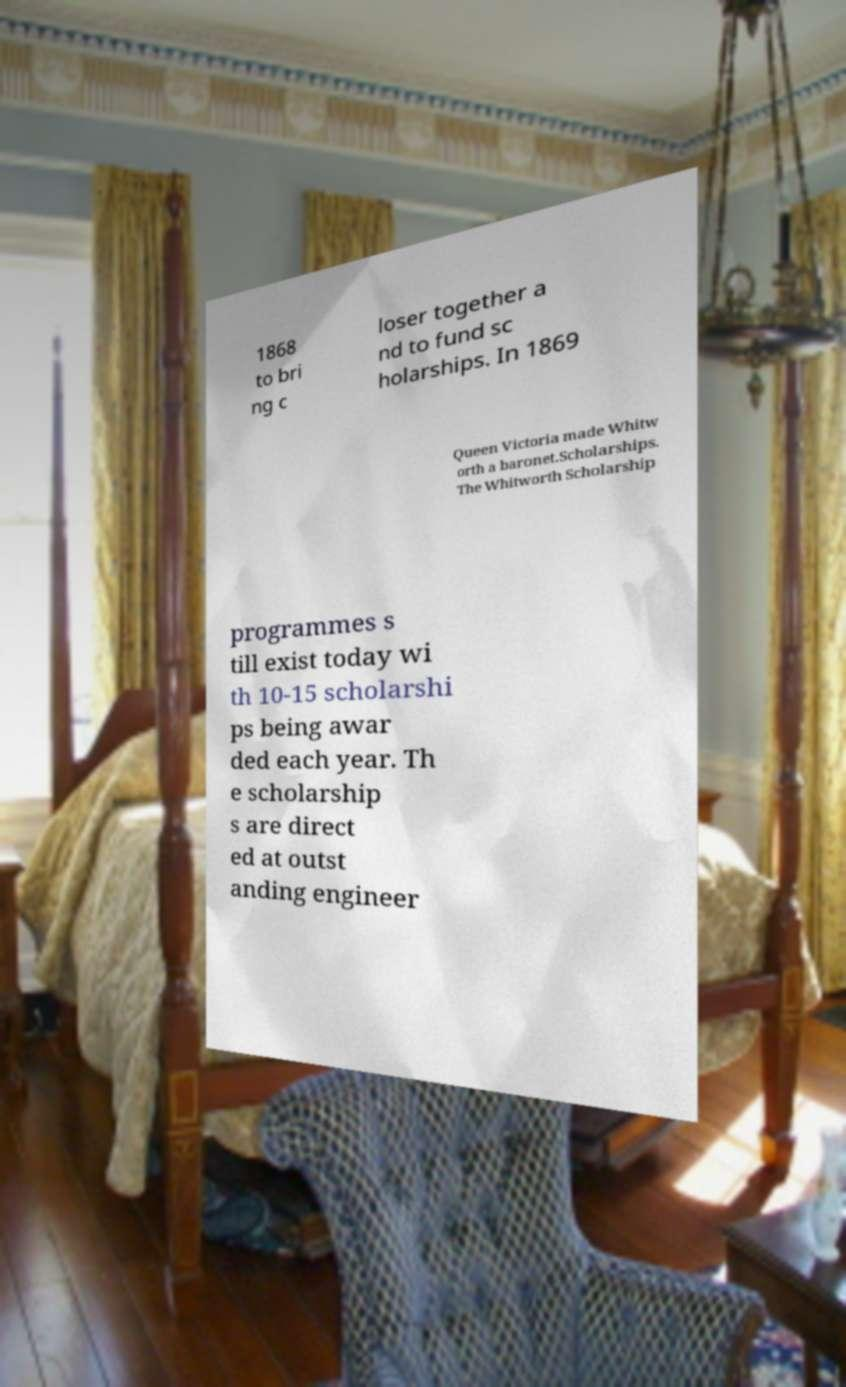What messages or text are displayed in this image? I need them in a readable, typed format. 1868 to bri ng c loser together a nd to fund sc holarships. In 1869 Queen Victoria made Whitw orth a baronet.Scholarships. The Whitworth Scholarship programmes s till exist today wi th 10-15 scholarshi ps being awar ded each year. Th e scholarship s are direct ed at outst anding engineer 